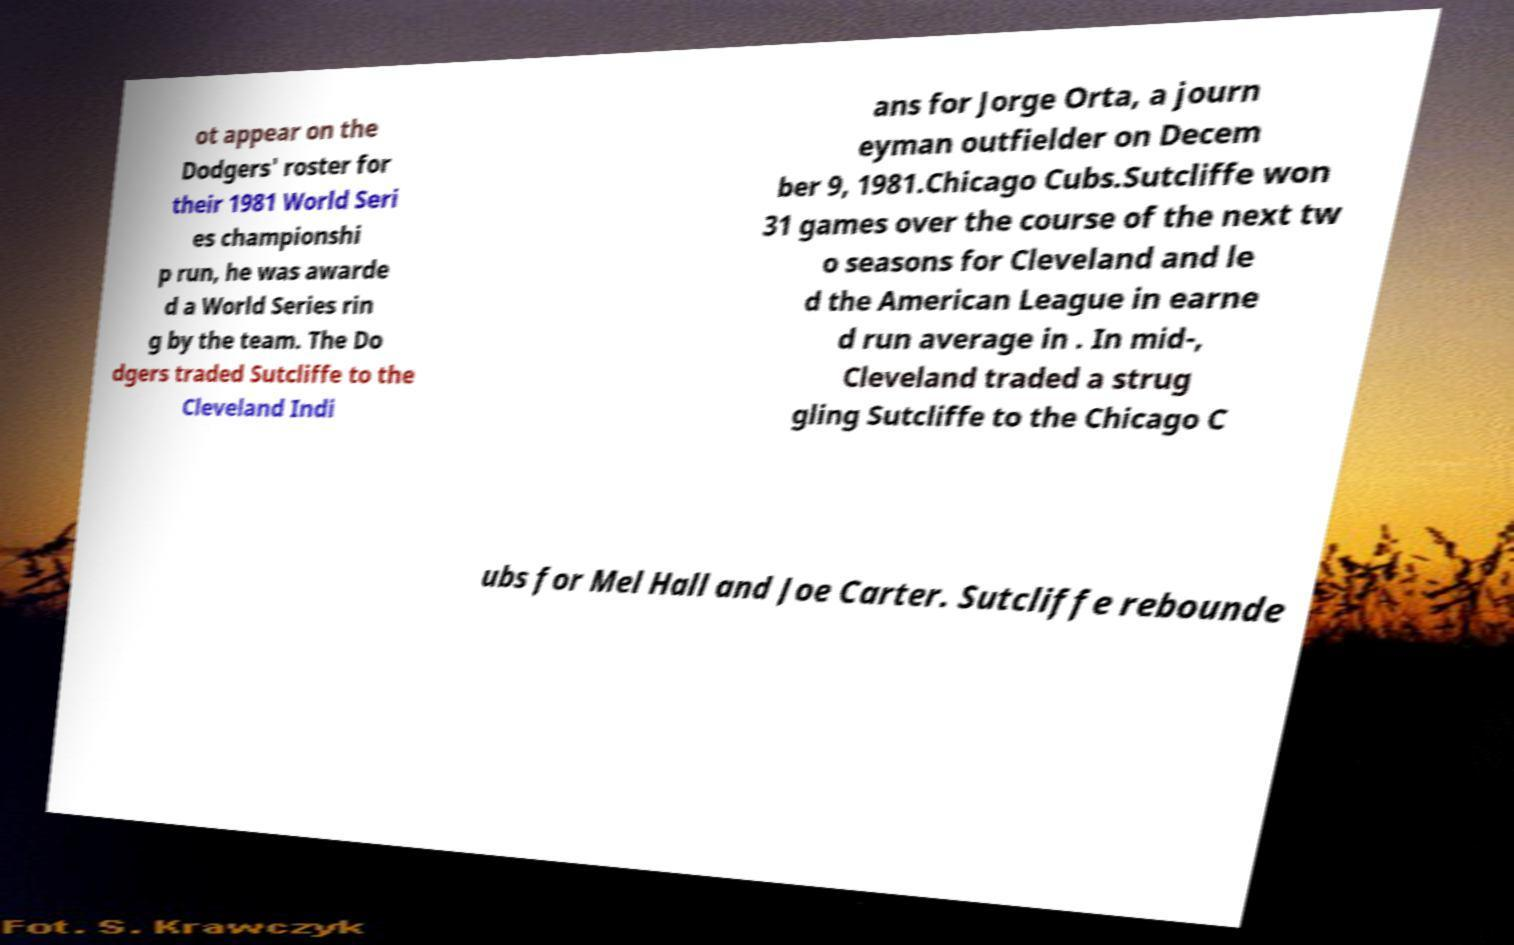Can you read and provide the text displayed in the image?This photo seems to have some interesting text. Can you extract and type it out for me? ot appear on the Dodgers' roster for their 1981 World Seri es championshi p run, he was awarde d a World Series rin g by the team. The Do dgers traded Sutcliffe to the Cleveland Indi ans for Jorge Orta, a journ eyman outfielder on Decem ber 9, 1981.Chicago Cubs.Sutcliffe won 31 games over the course of the next tw o seasons for Cleveland and le d the American League in earne d run average in . In mid-, Cleveland traded a strug gling Sutcliffe to the Chicago C ubs for Mel Hall and Joe Carter. Sutcliffe rebounde 